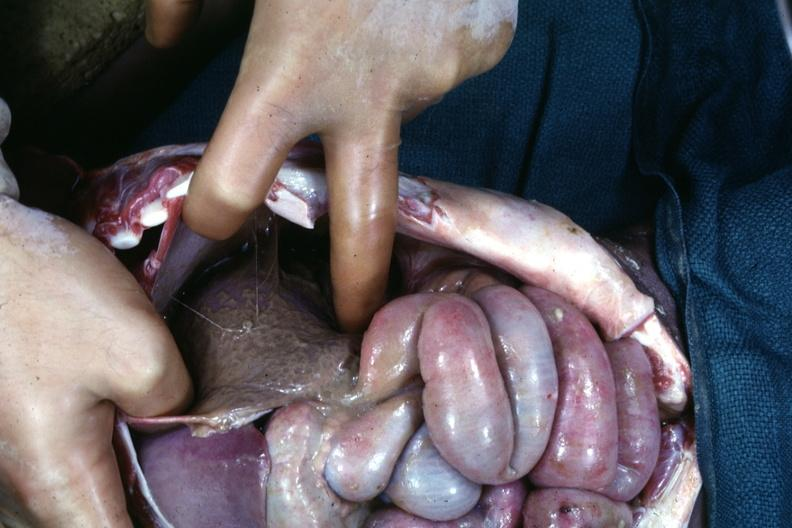does omphalocele see other slides?
Answer the question using a single word or phrase. No 